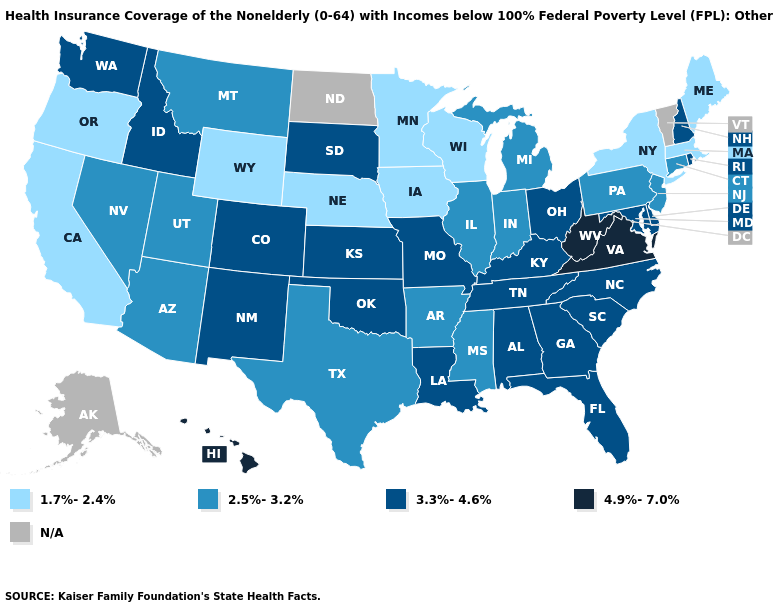What is the value of Virginia?
Keep it brief. 4.9%-7.0%. Which states hav the highest value in the MidWest?
Keep it brief. Kansas, Missouri, Ohio, South Dakota. What is the value of Georgia?
Keep it brief. 3.3%-4.6%. Which states have the lowest value in the USA?
Quick response, please. California, Iowa, Maine, Massachusetts, Minnesota, Nebraska, New York, Oregon, Wisconsin, Wyoming. What is the value of New York?
Write a very short answer. 1.7%-2.4%. Which states hav the highest value in the Northeast?
Write a very short answer. New Hampshire, Rhode Island. What is the value of Montana?
Keep it brief. 2.5%-3.2%. Does Georgia have the lowest value in the South?
Answer briefly. No. Does the map have missing data?
Give a very brief answer. Yes. What is the lowest value in the MidWest?
Keep it brief. 1.7%-2.4%. What is the highest value in the Northeast ?
Quick response, please. 3.3%-4.6%. Name the states that have a value in the range 1.7%-2.4%?
Keep it brief. California, Iowa, Maine, Massachusetts, Minnesota, Nebraska, New York, Oregon, Wisconsin, Wyoming. 